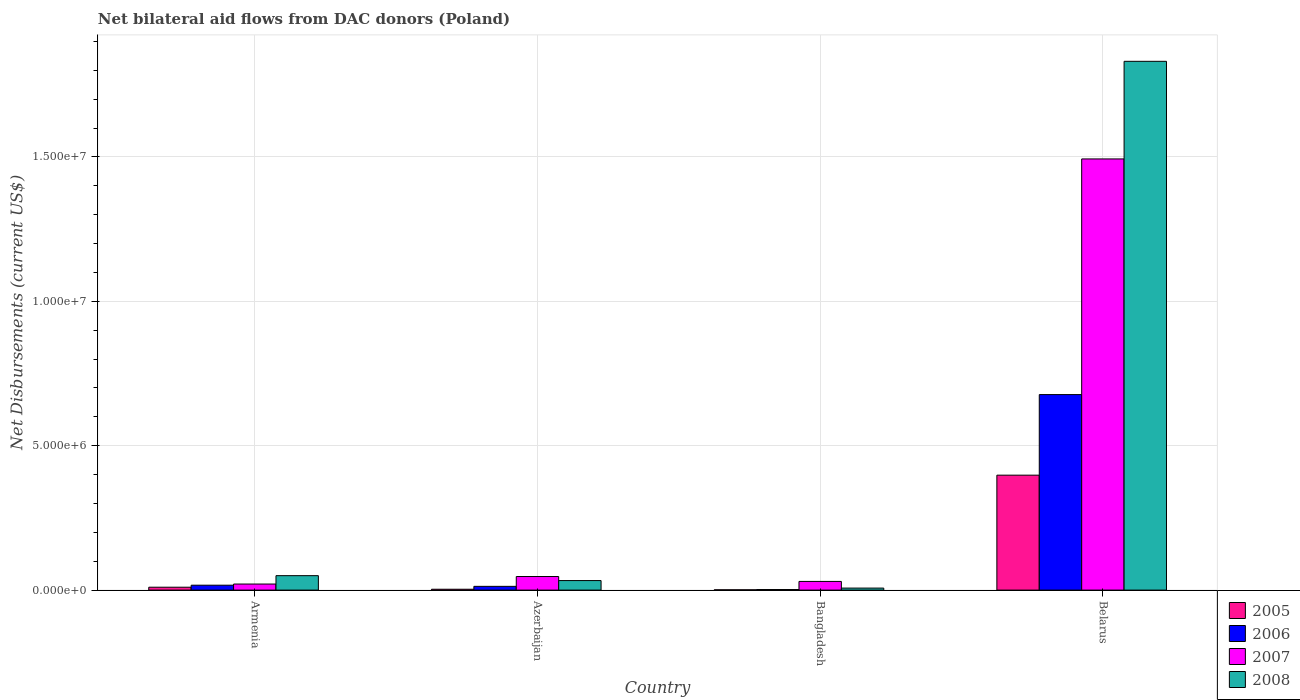Are the number of bars per tick equal to the number of legend labels?
Give a very brief answer. Yes. Are the number of bars on each tick of the X-axis equal?
Offer a terse response. Yes. What is the label of the 4th group of bars from the left?
Provide a short and direct response. Belarus. What is the net bilateral aid flows in 2008 in Belarus?
Give a very brief answer. 1.83e+07. Across all countries, what is the maximum net bilateral aid flows in 2005?
Your answer should be very brief. 3.98e+06. Across all countries, what is the minimum net bilateral aid flows in 2008?
Offer a very short reply. 7.00e+04. In which country was the net bilateral aid flows in 2008 maximum?
Keep it short and to the point. Belarus. In which country was the net bilateral aid flows in 2007 minimum?
Keep it short and to the point. Armenia. What is the total net bilateral aid flows in 2006 in the graph?
Your response must be concise. 7.09e+06. What is the difference between the net bilateral aid flows in 2008 in Armenia and that in Azerbaijan?
Offer a very short reply. 1.70e+05. What is the difference between the net bilateral aid flows in 2005 in Belarus and the net bilateral aid flows in 2007 in Azerbaijan?
Your answer should be very brief. 3.51e+06. What is the average net bilateral aid flows in 2007 per country?
Make the answer very short. 3.98e+06. What is the difference between the net bilateral aid flows of/in 2006 and net bilateral aid flows of/in 2008 in Belarus?
Ensure brevity in your answer.  -1.15e+07. In how many countries, is the net bilateral aid flows in 2008 greater than 5000000 US$?
Your answer should be very brief. 1. What is the ratio of the net bilateral aid flows in 2007 in Armenia to that in Belarus?
Your answer should be compact. 0.01. What is the difference between the highest and the second highest net bilateral aid flows in 2006?
Your response must be concise. 6.60e+06. What is the difference between the highest and the lowest net bilateral aid flows in 2007?
Your response must be concise. 1.47e+07. Is it the case that in every country, the sum of the net bilateral aid flows in 2006 and net bilateral aid flows in 2005 is greater than the sum of net bilateral aid flows in 2007 and net bilateral aid flows in 2008?
Offer a very short reply. No. What does the 2nd bar from the right in Armenia represents?
Your response must be concise. 2007. How many bars are there?
Ensure brevity in your answer.  16. Are the values on the major ticks of Y-axis written in scientific E-notation?
Keep it short and to the point. Yes. What is the title of the graph?
Make the answer very short. Net bilateral aid flows from DAC donors (Poland). Does "1964" appear as one of the legend labels in the graph?
Ensure brevity in your answer.  No. What is the label or title of the X-axis?
Offer a terse response. Country. What is the label or title of the Y-axis?
Give a very brief answer. Net Disbursements (current US$). What is the Net Disbursements (current US$) of 2005 in Armenia?
Your response must be concise. 1.00e+05. What is the Net Disbursements (current US$) of 2007 in Armenia?
Provide a succinct answer. 2.10e+05. What is the Net Disbursements (current US$) in 2008 in Armenia?
Give a very brief answer. 5.00e+05. What is the Net Disbursements (current US$) in 2005 in Azerbaijan?
Your response must be concise. 3.00e+04. What is the Net Disbursements (current US$) of 2006 in Azerbaijan?
Your answer should be compact. 1.30e+05. What is the Net Disbursements (current US$) in 2007 in Azerbaijan?
Make the answer very short. 4.70e+05. What is the Net Disbursements (current US$) in 2008 in Azerbaijan?
Your answer should be compact. 3.30e+05. What is the Net Disbursements (current US$) of 2005 in Bangladesh?
Provide a short and direct response. 10000. What is the Net Disbursements (current US$) in 2006 in Bangladesh?
Offer a terse response. 2.00e+04. What is the Net Disbursements (current US$) in 2005 in Belarus?
Ensure brevity in your answer.  3.98e+06. What is the Net Disbursements (current US$) in 2006 in Belarus?
Provide a succinct answer. 6.77e+06. What is the Net Disbursements (current US$) of 2007 in Belarus?
Provide a succinct answer. 1.49e+07. What is the Net Disbursements (current US$) in 2008 in Belarus?
Provide a succinct answer. 1.83e+07. Across all countries, what is the maximum Net Disbursements (current US$) in 2005?
Your answer should be very brief. 3.98e+06. Across all countries, what is the maximum Net Disbursements (current US$) in 2006?
Your response must be concise. 6.77e+06. Across all countries, what is the maximum Net Disbursements (current US$) in 2007?
Your answer should be compact. 1.49e+07. Across all countries, what is the maximum Net Disbursements (current US$) in 2008?
Your answer should be compact. 1.83e+07. Across all countries, what is the minimum Net Disbursements (current US$) of 2006?
Give a very brief answer. 2.00e+04. Across all countries, what is the minimum Net Disbursements (current US$) of 2007?
Keep it short and to the point. 2.10e+05. What is the total Net Disbursements (current US$) of 2005 in the graph?
Offer a very short reply. 4.12e+06. What is the total Net Disbursements (current US$) in 2006 in the graph?
Give a very brief answer. 7.09e+06. What is the total Net Disbursements (current US$) in 2007 in the graph?
Your response must be concise. 1.59e+07. What is the total Net Disbursements (current US$) in 2008 in the graph?
Give a very brief answer. 1.92e+07. What is the difference between the Net Disbursements (current US$) in 2007 in Armenia and that in Azerbaijan?
Make the answer very short. -2.60e+05. What is the difference between the Net Disbursements (current US$) in 2006 in Armenia and that in Bangladesh?
Give a very brief answer. 1.50e+05. What is the difference between the Net Disbursements (current US$) in 2008 in Armenia and that in Bangladesh?
Offer a terse response. 4.30e+05. What is the difference between the Net Disbursements (current US$) of 2005 in Armenia and that in Belarus?
Keep it short and to the point. -3.88e+06. What is the difference between the Net Disbursements (current US$) of 2006 in Armenia and that in Belarus?
Offer a very short reply. -6.60e+06. What is the difference between the Net Disbursements (current US$) of 2007 in Armenia and that in Belarus?
Ensure brevity in your answer.  -1.47e+07. What is the difference between the Net Disbursements (current US$) in 2008 in Armenia and that in Belarus?
Keep it short and to the point. -1.78e+07. What is the difference between the Net Disbursements (current US$) in 2005 in Azerbaijan and that in Bangladesh?
Ensure brevity in your answer.  2.00e+04. What is the difference between the Net Disbursements (current US$) of 2005 in Azerbaijan and that in Belarus?
Your answer should be very brief. -3.95e+06. What is the difference between the Net Disbursements (current US$) of 2006 in Azerbaijan and that in Belarus?
Provide a succinct answer. -6.64e+06. What is the difference between the Net Disbursements (current US$) of 2007 in Azerbaijan and that in Belarus?
Provide a short and direct response. -1.45e+07. What is the difference between the Net Disbursements (current US$) of 2008 in Azerbaijan and that in Belarus?
Your answer should be very brief. -1.80e+07. What is the difference between the Net Disbursements (current US$) of 2005 in Bangladesh and that in Belarus?
Your answer should be compact. -3.97e+06. What is the difference between the Net Disbursements (current US$) of 2006 in Bangladesh and that in Belarus?
Your answer should be very brief. -6.75e+06. What is the difference between the Net Disbursements (current US$) of 2007 in Bangladesh and that in Belarus?
Your answer should be very brief. -1.46e+07. What is the difference between the Net Disbursements (current US$) of 2008 in Bangladesh and that in Belarus?
Provide a succinct answer. -1.82e+07. What is the difference between the Net Disbursements (current US$) of 2005 in Armenia and the Net Disbursements (current US$) of 2007 in Azerbaijan?
Make the answer very short. -3.70e+05. What is the difference between the Net Disbursements (current US$) of 2006 in Armenia and the Net Disbursements (current US$) of 2007 in Azerbaijan?
Your answer should be very brief. -3.00e+05. What is the difference between the Net Disbursements (current US$) of 2007 in Armenia and the Net Disbursements (current US$) of 2008 in Azerbaijan?
Offer a very short reply. -1.20e+05. What is the difference between the Net Disbursements (current US$) in 2005 in Armenia and the Net Disbursements (current US$) in 2007 in Bangladesh?
Ensure brevity in your answer.  -2.00e+05. What is the difference between the Net Disbursements (current US$) of 2006 in Armenia and the Net Disbursements (current US$) of 2007 in Bangladesh?
Provide a succinct answer. -1.30e+05. What is the difference between the Net Disbursements (current US$) of 2006 in Armenia and the Net Disbursements (current US$) of 2008 in Bangladesh?
Provide a succinct answer. 1.00e+05. What is the difference between the Net Disbursements (current US$) in 2005 in Armenia and the Net Disbursements (current US$) in 2006 in Belarus?
Make the answer very short. -6.67e+06. What is the difference between the Net Disbursements (current US$) of 2005 in Armenia and the Net Disbursements (current US$) of 2007 in Belarus?
Provide a short and direct response. -1.48e+07. What is the difference between the Net Disbursements (current US$) in 2005 in Armenia and the Net Disbursements (current US$) in 2008 in Belarus?
Keep it short and to the point. -1.82e+07. What is the difference between the Net Disbursements (current US$) of 2006 in Armenia and the Net Disbursements (current US$) of 2007 in Belarus?
Offer a terse response. -1.48e+07. What is the difference between the Net Disbursements (current US$) in 2006 in Armenia and the Net Disbursements (current US$) in 2008 in Belarus?
Make the answer very short. -1.81e+07. What is the difference between the Net Disbursements (current US$) of 2007 in Armenia and the Net Disbursements (current US$) of 2008 in Belarus?
Offer a terse response. -1.81e+07. What is the difference between the Net Disbursements (current US$) of 2006 in Azerbaijan and the Net Disbursements (current US$) of 2007 in Bangladesh?
Provide a short and direct response. -1.70e+05. What is the difference between the Net Disbursements (current US$) in 2006 in Azerbaijan and the Net Disbursements (current US$) in 2008 in Bangladesh?
Keep it short and to the point. 6.00e+04. What is the difference between the Net Disbursements (current US$) in 2005 in Azerbaijan and the Net Disbursements (current US$) in 2006 in Belarus?
Make the answer very short. -6.74e+06. What is the difference between the Net Disbursements (current US$) of 2005 in Azerbaijan and the Net Disbursements (current US$) of 2007 in Belarus?
Your answer should be very brief. -1.49e+07. What is the difference between the Net Disbursements (current US$) in 2005 in Azerbaijan and the Net Disbursements (current US$) in 2008 in Belarus?
Keep it short and to the point. -1.83e+07. What is the difference between the Net Disbursements (current US$) in 2006 in Azerbaijan and the Net Disbursements (current US$) in 2007 in Belarus?
Provide a succinct answer. -1.48e+07. What is the difference between the Net Disbursements (current US$) in 2006 in Azerbaijan and the Net Disbursements (current US$) in 2008 in Belarus?
Your answer should be compact. -1.82e+07. What is the difference between the Net Disbursements (current US$) in 2007 in Azerbaijan and the Net Disbursements (current US$) in 2008 in Belarus?
Your answer should be very brief. -1.78e+07. What is the difference between the Net Disbursements (current US$) of 2005 in Bangladesh and the Net Disbursements (current US$) of 2006 in Belarus?
Provide a succinct answer. -6.76e+06. What is the difference between the Net Disbursements (current US$) in 2005 in Bangladesh and the Net Disbursements (current US$) in 2007 in Belarus?
Give a very brief answer. -1.49e+07. What is the difference between the Net Disbursements (current US$) in 2005 in Bangladesh and the Net Disbursements (current US$) in 2008 in Belarus?
Ensure brevity in your answer.  -1.83e+07. What is the difference between the Net Disbursements (current US$) of 2006 in Bangladesh and the Net Disbursements (current US$) of 2007 in Belarus?
Provide a succinct answer. -1.49e+07. What is the difference between the Net Disbursements (current US$) in 2006 in Bangladesh and the Net Disbursements (current US$) in 2008 in Belarus?
Provide a short and direct response. -1.83e+07. What is the difference between the Net Disbursements (current US$) of 2007 in Bangladesh and the Net Disbursements (current US$) of 2008 in Belarus?
Provide a short and direct response. -1.80e+07. What is the average Net Disbursements (current US$) in 2005 per country?
Your answer should be compact. 1.03e+06. What is the average Net Disbursements (current US$) of 2006 per country?
Provide a short and direct response. 1.77e+06. What is the average Net Disbursements (current US$) in 2007 per country?
Offer a terse response. 3.98e+06. What is the average Net Disbursements (current US$) in 2008 per country?
Provide a short and direct response. 4.80e+06. What is the difference between the Net Disbursements (current US$) in 2005 and Net Disbursements (current US$) in 2006 in Armenia?
Offer a very short reply. -7.00e+04. What is the difference between the Net Disbursements (current US$) in 2005 and Net Disbursements (current US$) in 2007 in Armenia?
Ensure brevity in your answer.  -1.10e+05. What is the difference between the Net Disbursements (current US$) in 2005 and Net Disbursements (current US$) in 2008 in Armenia?
Your response must be concise. -4.00e+05. What is the difference between the Net Disbursements (current US$) of 2006 and Net Disbursements (current US$) of 2008 in Armenia?
Give a very brief answer. -3.30e+05. What is the difference between the Net Disbursements (current US$) in 2007 and Net Disbursements (current US$) in 2008 in Armenia?
Provide a short and direct response. -2.90e+05. What is the difference between the Net Disbursements (current US$) of 2005 and Net Disbursements (current US$) of 2006 in Azerbaijan?
Offer a very short reply. -1.00e+05. What is the difference between the Net Disbursements (current US$) of 2005 and Net Disbursements (current US$) of 2007 in Azerbaijan?
Provide a succinct answer. -4.40e+05. What is the difference between the Net Disbursements (current US$) of 2006 and Net Disbursements (current US$) of 2007 in Azerbaijan?
Provide a succinct answer. -3.40e+05. What is the difference between the Net Disbursements (current US$) of 2007 and Net Disbursements (current US$) of 2008 in Azerbaijan?
Offer a terse response. 1.40e+05. What is the difference between the Net Disbursements (current US$) of 2006 and Net Disbursements (current US$) of 2007 in Bangladesh?
Your answer should be very brief. -2.80e+05. What is the difference between the Net Disbursements (current US$) of 2006 and Net Disbursements (current US$) of 2008 in Bangladesh?
Provide a short and direct response. -5.00e+04. What is the difference between the Net Disbursements (current US$) of 2005 and Net Disbursements (current US$) of 2006 in Belarus?
Your response must be concise. -2.79e+06. What is the difference between the Net Disbursements (current US$) of 2005 and Net Disbursements (current US$) of 2007 in Belarus?
Provide a succinct answer. -1.10e+07. What is the difference between the Net Disbursements (current US$) of 2005 and Net Disbursements (current US$) of 2008 in Belarus?
Make the answer very short. -1.43e+07. What is the difference between the Net Disbursements (current US$) of 2006 and Net Disbursements (current US$) of 2007 in Belarus?
Make the answer very short. -8.16e+06. What is the difference between the Net Disbursements (current US$) in 2006 and Net Disbursements (current US$) in 2008 in Belarus?
Provide a short and direct response. -1.15e+07. What is the difference between the Net Disbursements (current US$) in 2007 and Net Disbursements (current US$) in 2008 in Belarus?
Provide a succinct answer. -3.38e+06. What is the ratio of the Net Disbursements (current US$) of 2006 in Armenia to that in Azerbaijan?
Keep it short and to the point. 1.31. What is the ratio of the Net Disbursements (current US$) of 2007 in Armenia to that in Azerbaijan?
Ensure brevity in your answer.  0.45. What is the ratio of the Net Disbursements (current US$) in 2008 in Armenia to that in Azerbaijan?
Provide a succinct answer. 1.52. What is the ratio of the Net Disbursements (current US$) of 2007 in Armenia to that in Bangladesh?
Give a very brief answer. 0.7. What is the ratio of the Net Disbursements (current US$) of 2008 in Armenia to that in Bangladesh?
Make the answer very short. 7.14. What is the ratio of the Net Disbursements (current US$) of 2005 in Armenia to that in Belarus?
Provide a succinct answer. 0.03. What is the ratio of the Net Disbursements (current US$) of 2006 in Armenia to that in Belarus?
Offer a very short reply. 0.03. What is the ratio of the Net Disbursements (current US$) of 2007 in Armenia to that in Belarus?
Your response must be concise. 0.01. What is the ratio of the Net Disbursements (current US$) in 2008 in Armenia to that in Belarus?
Your response must be concise. 0.03. What is the ratio of the Net Disbursements (current US$) in 2007 in Azerbaijan to that in Bangladesh?
Your answer should be compact. 1.57. What is the ratio of the Net Disbursements (current US$) of 2008 in Azerbaijan to that in Bangladesh?
Provide a succinct answer. 4.71. What is the ratio of the Net Disbursements (current US$) of 2005 in Azerbaijan to that in Belarus?
Your response must be concise. 0.01. What is the ratio of the Net Disbursements (current US$) of 2006 in Azerbaijan to that in Belarus?
Provide a short and direct response. 0.02. What is the ratio of the Net Disbursements (current US$) in 2007 in Azerbaijan to that in Belarus?
Offer a very short reply. 0.03. What is the ratio of the Net Disbursements (current US$) in 2008 in Azerbaijan to that in Belarus?
Your response must be concise. 0.02. What is the ratio of the Net Disbursements (current US$) of 2005 in Bangladesh to that in Belarus?
Offer a terse response. 0. What is the ratio of the Net Disbursements (current US$) in 2006 in Bangladesh to that in Belarus?
Keep it short and to the point. 0. What is the ratio of the Net Disbursements (current US$) of 2007 in Bangladesh to that in Belarus?
Keep it short and to the point. 0.02. What is the ratio of the Net Disbursements (current US$) in 2008 in Bangladesh to that in Belarus?
Give a very brief answer. 0. What is the difference between the highest and the second highest Net Disbursements (current US$) in 2005?
Your answer should be compact. 3.88e+06. What is the difference between the highest and the second highest Net Disbursements (current US$) of 2006?
Your answer should be compact. 6.60e+06. What is the difference between the highest and the second highest Net Disbursements (current US$) of 2007?
Keep it short and to the point. 1.45e+07. What is the difference between the highest and the second highest Net Disbursements (current US$) in 2008?
Make the answer very short. 1.78e+07. What is the difference between the highest and the lowest Net Disbursements (current US$) of 2005?
Ensure brevity in your answer.  3.97e+06. What is the difference between the highest and the lowest Net Disbursements (current US$) of 2006?
Offer a terse response. 6.75e+06. What is the difference between the highest and the lowest Net Disbursements (current US$) of 2007?
Your answer should be very brief. 1.47e+07. What is the difference between the highest and the lowest Net Disbursements (current US$) of 2008?
Give a very brief answer. 1.82e+07. 